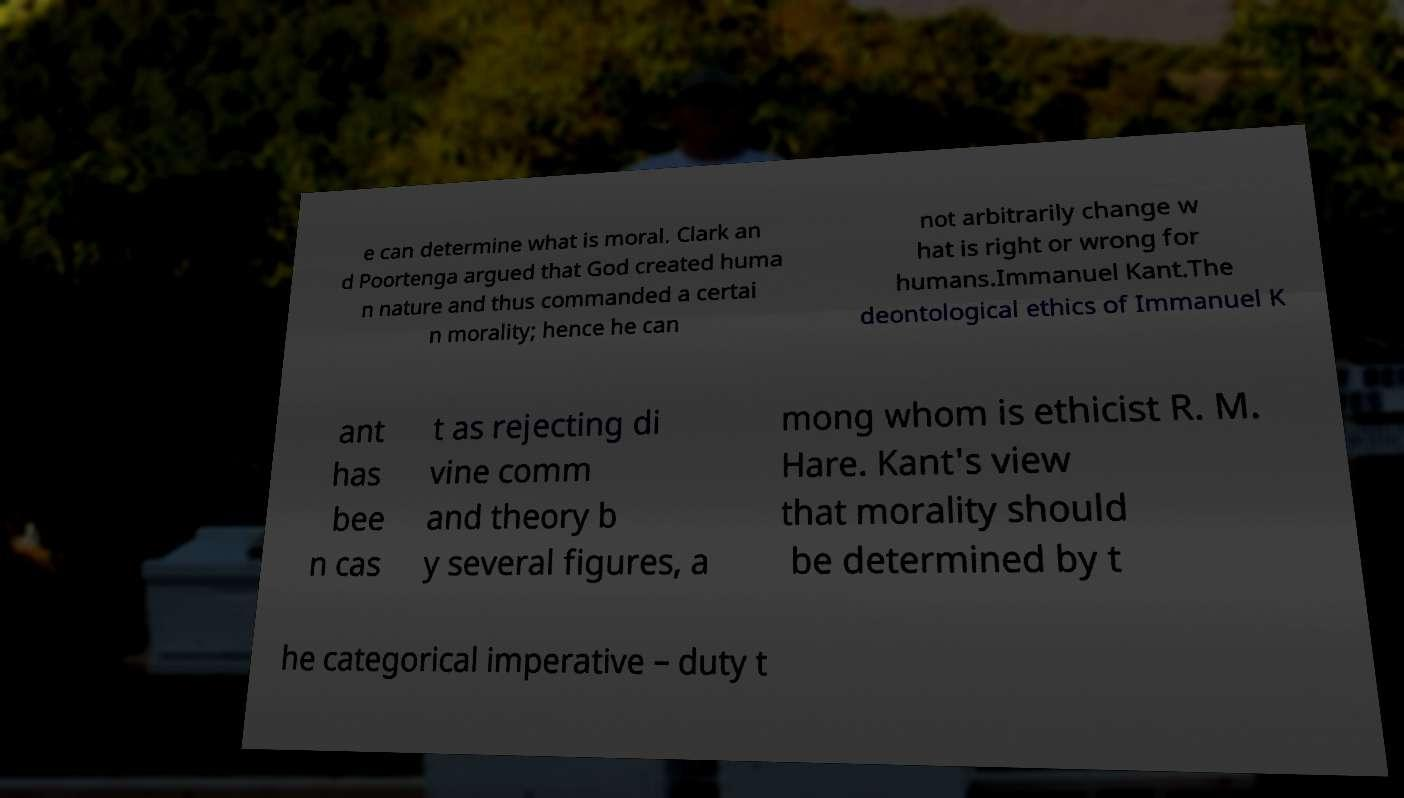Can you read and provide the text displayed in the image?This photo seems to have some interesting text. Can you extract and type it out for me? e can determine what is moral. Clark an d Poortenga argued that God created huma n nature and thus commanded a certai n morality; hence he can not arbitrarily change w hat is right or wrong for humans.Immanuel Kant.The deontological ethics of Immanuel K ant has bee n cas t as rejecting di vine comm and theory b y several figures, a mong whom is ethicist R. M. Hare. Kant's view that morality should be determined by t he categorical imperative – duty t 